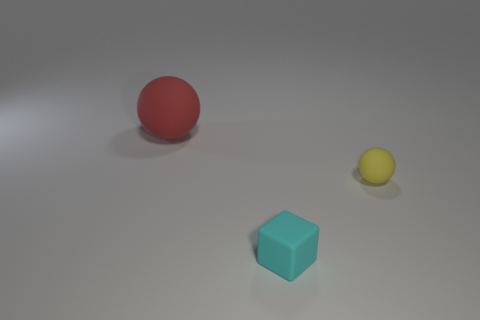What number of things are either tiny gray metal blocks or objects that are right of the big matte ball?
Your answer should be compact. 2. What is the color of the block that is made of the same material as the large red sphere?
Your answer should be compact. Cyan. How many objects are either tiny cyan blocks or blue spheres?
Offer a terse response. 1. There is a rubber cube that is the same size as the yellow matte thing; what color is it?
Your response must be concise. Cyan. What number of objects are either things that are behind the small yellow rubber thing or tiny purple shiny spheres?
Give a very brief answer. 1. What number of other objects are there of the same size as the red rubber sphere?
Keep it short and to the point. 0. What is the size of the rubber thing behind the yellow object?
Keep it short and to the point. Large. What is the shape of the big red object that is made of the same material as the cube?
Ensure brevity in your answer.  Sphere. Is there any other thing of the same color as the big matte ball?
Your response must be concise. No. What color is the ball on the left side of the sphere in front of the large thing?
Make the answer very short. Red. 